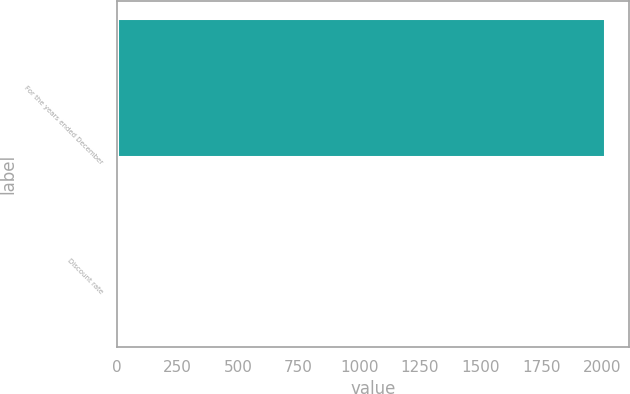Convert chart. <chart><loc_0><loc_0><loc_500><loc_500><bar_chart><fcel>For the years ended December<fcel>Discount rate<nl><fcel>2011<fcel>5.2<nl></chart> 